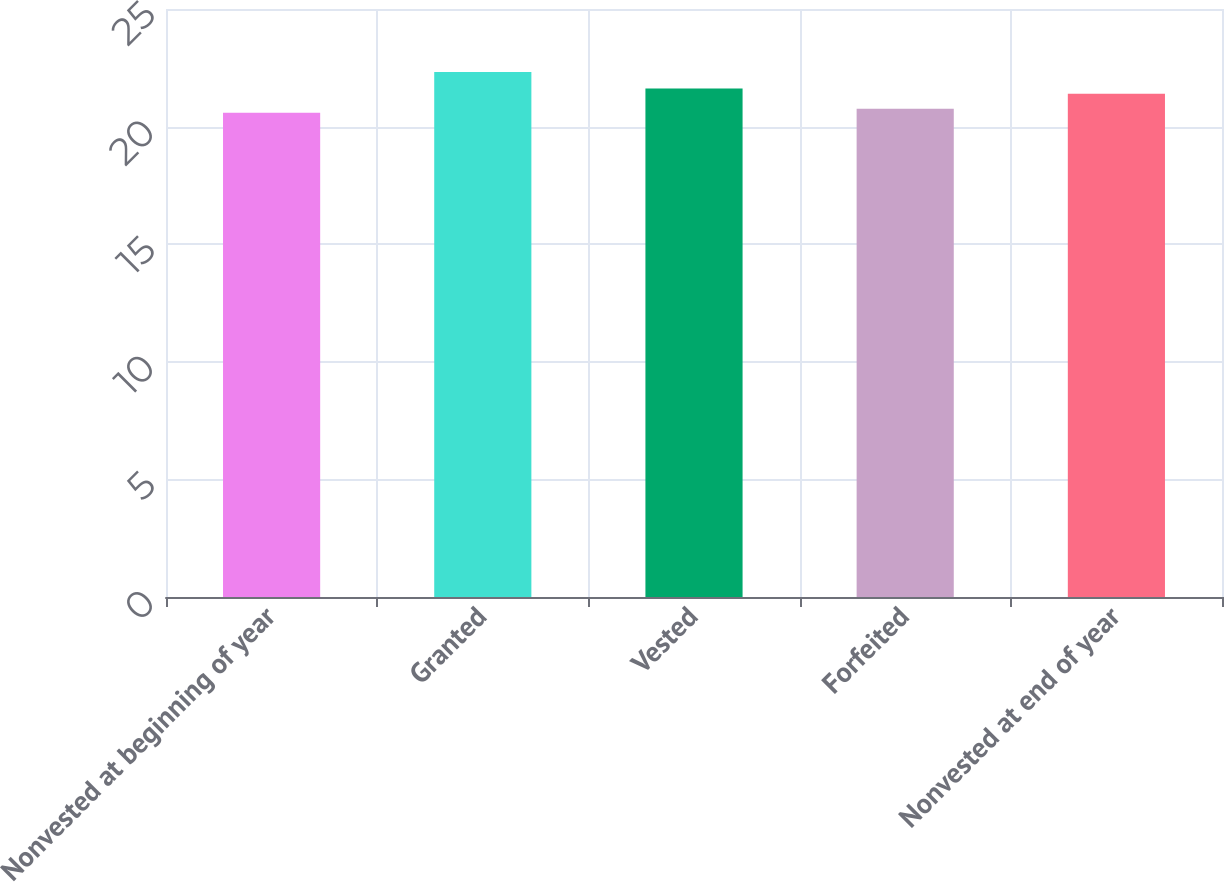Convert chart to OTSL. <chart><loc_0><loc_0><loc_500><loc_500><bar_chart><fcel>Nonvested at beginning of year<fcel>Granted<fcel>Vested<fcel>Forfeited<fcel>Nonvested at end of year<nl><fcel>20.59<fcel>22.32<fcel>21.62<fcel>20.76<fcel>21.4<nl></chart> 